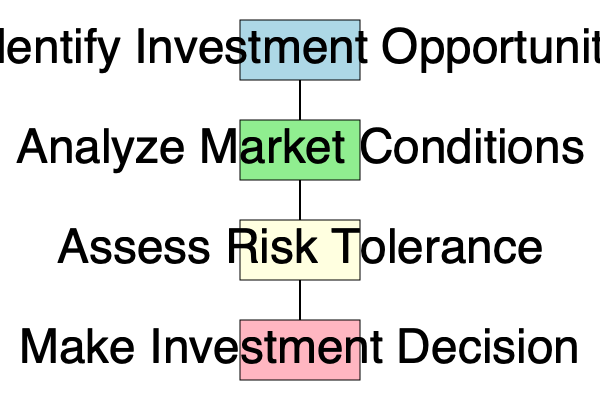According to the investment decision-making flowchart, which step directly precedes the final "Make Investment Decision" stage? To answer this question, we need to analyze the flowchart of the investment decision-making process:

1. The flowchart consists of four main stages, represented by colored rectangles.
2. The stages are connected by arrows, indicating the flow of the decision-making process.
3. The stages, in order from top to bottom, are:
   a. Identify Investment Opportunity (light blue)
   b. Analyze Market Conditions (light green)
   c. Assess Risk Tolerance (light yellow)
   d. Make Investment Decision (light pink)
4. The question asks about the step that directly precedes the final "Make Investment Decision" stage.
5. By following the arrows, we can see that the "Assess Risk Tolerance" stage (light yellow) is immediately above and connected to the "Make Investment Decision" stage.

Therefore, the step that directly precedes the final "Make Investment Decision" stage is "Assess Risk Tolerance."
Answer: Assess Risk Tolerance 